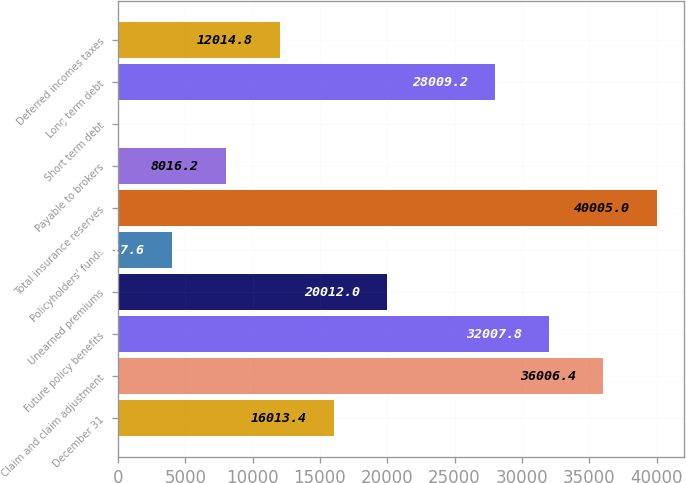Convert chart to OTSL. <chart><loc_0><loc_0><loc_500><loc_500><bar_chart><fcel>December 31<fcel>Claim and claim adjustment<fcel>Future policy benefits<fcel>Unearned premiums<fcel>Policyholders' funds<fcel>Total insurance reserves<fcel>Payable to brokers<fcel>Short term debt<fcel>Long term debt<fcel>Deferred incomes taxes<nl><fcel>16013.4<fcel>36006.4<fcel>32007.8<fcel>20012<fcel>4017.6<fcel>40005<fcel>8016.2<fcel>19<fcel>28009.2<fcel>12014.8<nl></chart> 